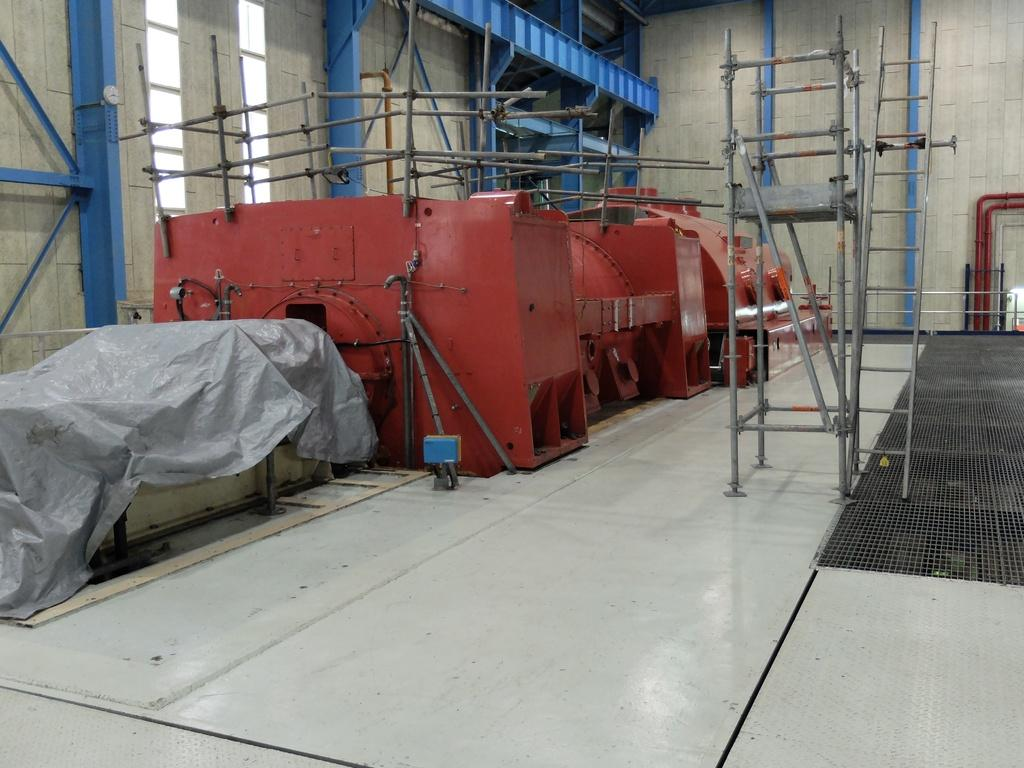What type of surface can be seen in the image? There is ground visible in the image. What is present on the ground? There are metallic objects on the ground. What is covering the ground? There is a cover on the ground. What is the main structure in the image? There is a wall in the image. What is attached to the wall? There is a metallic object on the wall. How can someone enter the area behind the wall? There is an entrance associated with the wall. What is used to reach higher areas in the image? There is a ladder in the image. What is the name of the girl playing with the tail in the image? There is no girl or tail present in the image. 